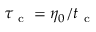<formula> <loc_0><loc_0><loc_500><loc_500>\tau _ { c } = \eta _ { 0 } / t _ { c }</formula> 